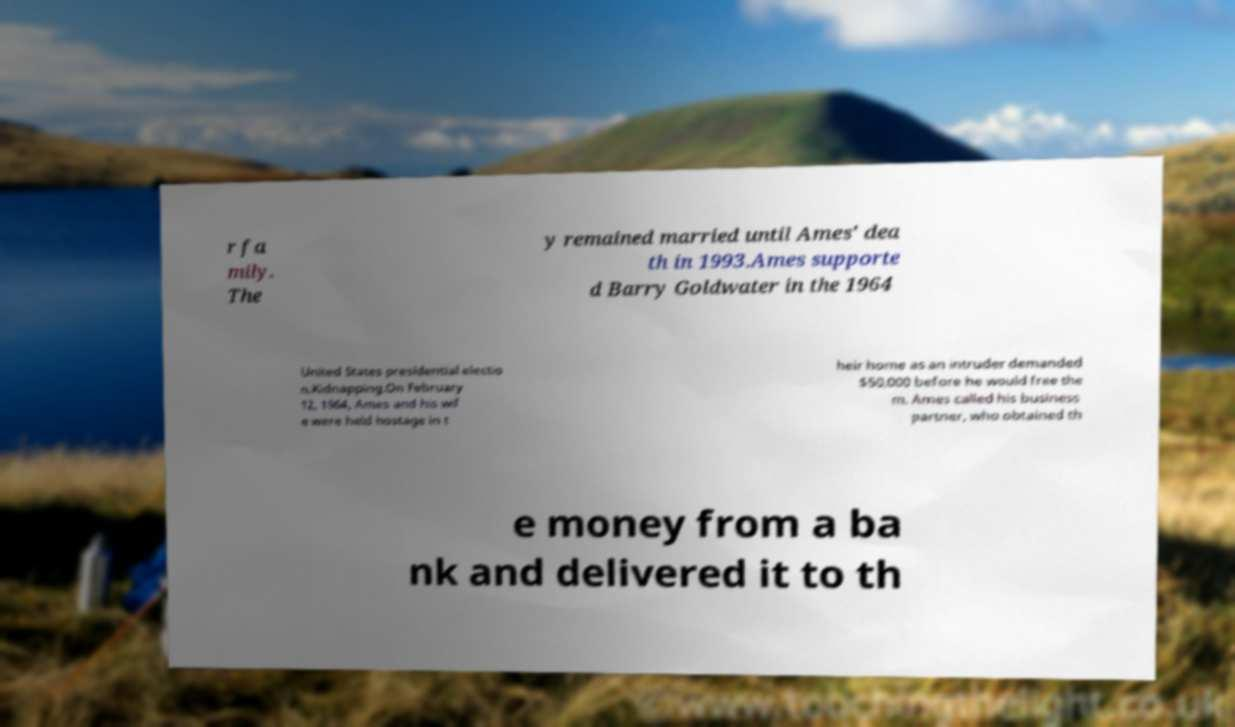What messages or text are displayed in this image? I need them in a readable, typed format. r fa mily. The y remained married until Ames' dea th in 1993.Ames supporte d Barry Goldwater in the 1964 United States presidential electio n.Kidnapping.On February 12, 1964, Ames and his wif e were held hostage in t heir home as an intruder demanded $50,000 before he would free the m. Ames called his business partner, who obtained th e money from a ba nk and delivered it to th 